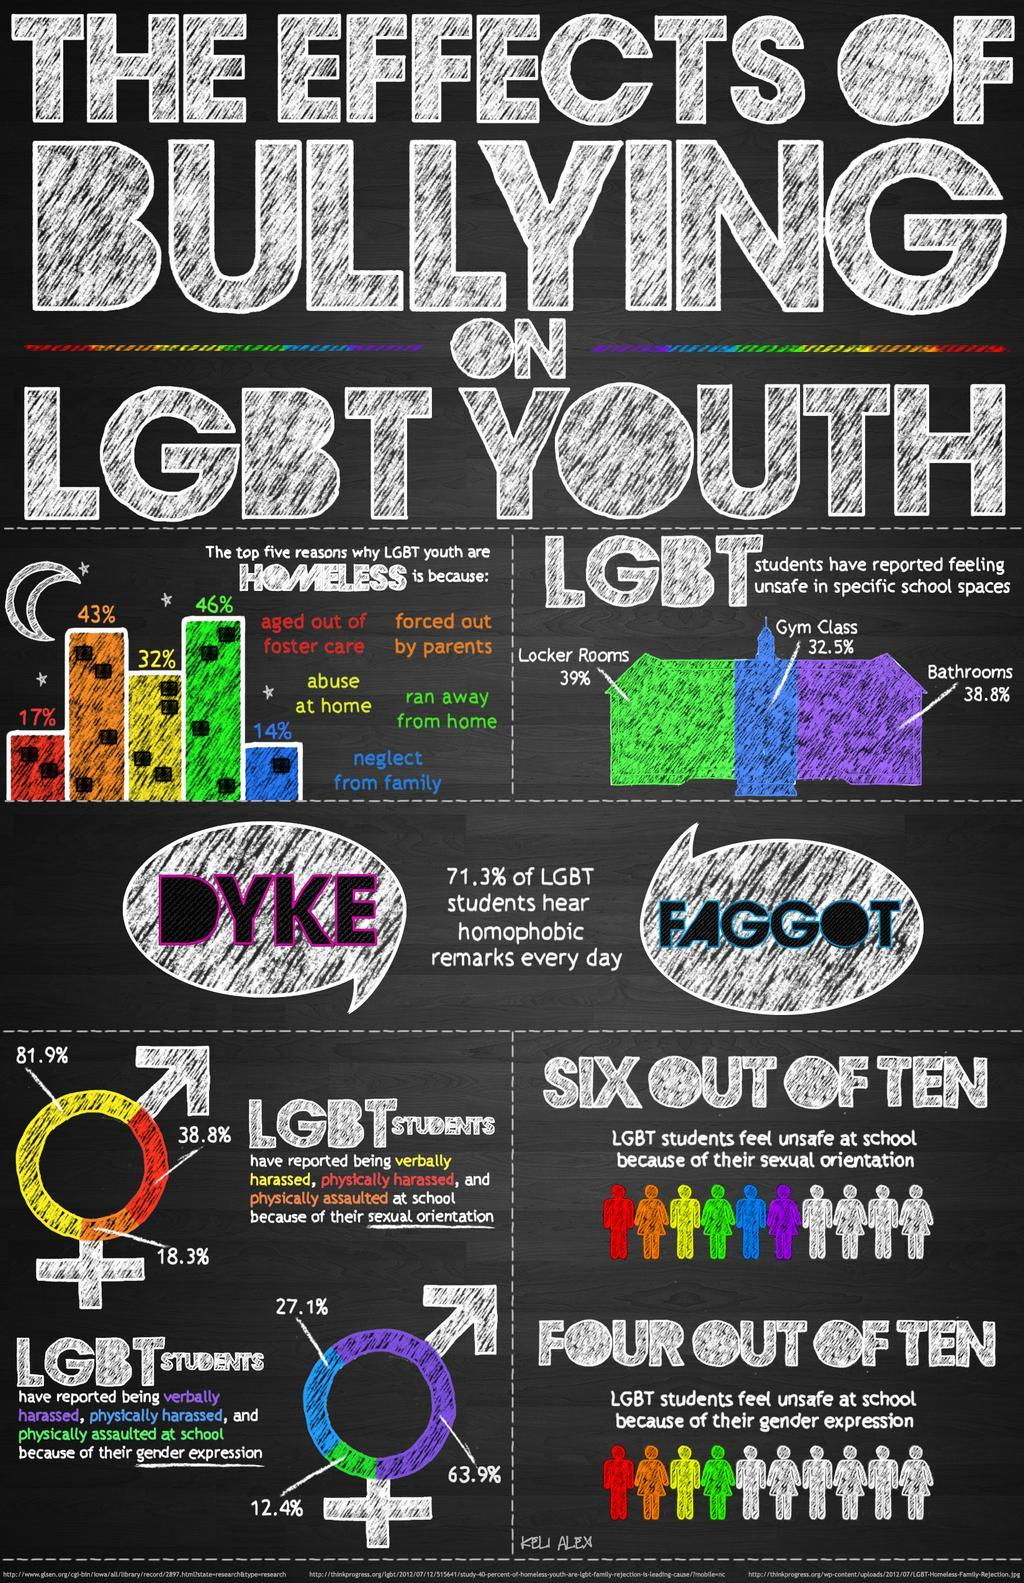Indicate a few pertinent items in this graphic. According to a report, 38.8% of LGBT students have reported feeling unsafe in school bathrooms. According to research, LGBT youth are disproportionately represented among homeless populations, with 14% reporting neglect from their families as the primary cause of their homelessness. According to a report, 38.8% of LGBT students have reported being physically harassed. According to a survey of LGBT students, 32.5% reported feeling unsafe in gym classes at school. According to a report, 81.9% of LGBT students have reported being verbally abused. 